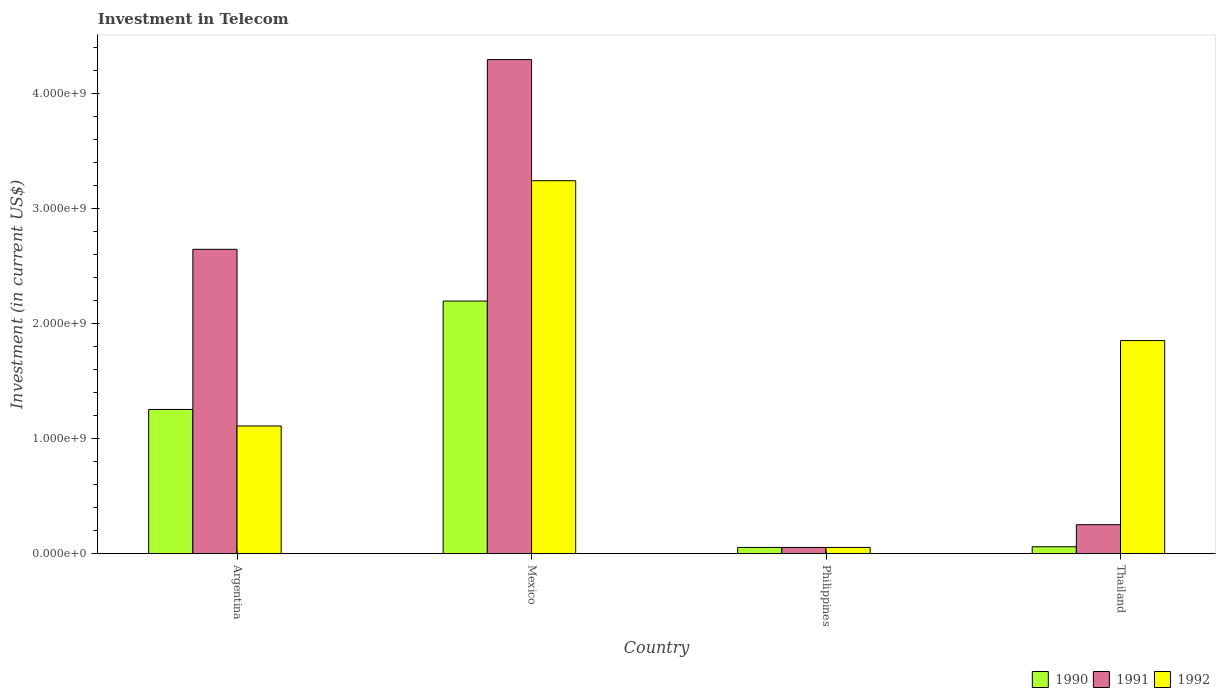How many different coloured bars are there?
Offer a very short reply. 3. How many groups of bars are there?
Give a very brief answer. 4. Are the number of bars per tick equal to the number of legend labels?
Your answer should be very brief. Yes. Are the number of bars on each tick of the X-axis equal?
Give a very brief answer. Yes. How many bars are there on the 1st tick from the left?
Your response must be concise. 3. What is the label of the 4th group of bars from the left?
Your answer should be very brief. Thailand. What is the amount invested in telecom in 1992 in Philippines?
Ensure brevity in your answer.  5.42e+07. Across all countries, what is the maximum amount invested in telecom in 1990?
Give a very brief answer. 2.20e+09. Across all countries, what is the minimum amount invested in telecom in 1990?
Your answer should be very brief. 5.42e+07. What is the total amount invested in telecom in 1992 in the graph?
Your answer should be very brief. 6.26e+09. What is the difference between the amount invested in telecom in 1990 in Argentina and that in Thailand?
Provide a succinct answer. 1.19e+09. What is the difference between the amount invested in telecom in 1990 in Thailand and the amount invested in telecom in 1991 in Mexico?
Offer a terse response. -4.24e+09. What is the average amount invested in telecom in 1992 per country?
Your response must be concise. 1.57e+09. What is the difference between the amount invested in telecom of/in 1990 and amount invested in telecom of/in 1991 in Mexico?
Give a very brief answer. -2.10e+09. What is the ratio of the amount invested in telecom in 1992 in Argentina to that in Mexico?
Provide a short and direct response. 0.34. What is the difference between the highest and the second highest amount invested in telecom in 1992?
Your response must be concise. 1.39e+09. What is the difference between the highest and the lowest amount invested in telecom in 1990?
Offer a terse response. 2.14e+09. Is the sum of the amount invested in telecom in 1990 in Argentina and Mexico greater than the maximum amount invested in telecom in 1991 across all countries?
Keep it short and to the point. No. What does the 1st bar from the right in Thailand represents?
Your answer should be very brief. 1992. Is it the case that in every country, the sum of the amount invested in telecom in 1992 and amount invested in telecom in 1991 is greater than the amount invested in telecom in 1990?
Keep it short and to the point. Yes. How many bars are there?
Ensure brevity in your answer.  12. Are all the bars in the graph horizontal?
Keep it short and to the point. No. How many countries are there in the graph?
Keep it short and to the point. 4. What is the difference between two consecutive major ticks on the Y-axis?
Your answer should be very brief. 1.00e+09. Where does the legend appear in the graph?
Offer a very short reply. Bottom right. How are the legend labels stacked?
Your answer should be compact. Horizontal. What is the title of the graph?
Ensure brevity in your answer.  Investment in Telecom. Does "1985" appear as one of the legend labels in the graph?
Ensure brevity in your answer.  No. What is the label or title of the Y-axis?
Your answer should be compact. Investment (in current US$). What is the Investment (in current US$) of 1990 in Argentina?
Your response must be concise. 1.25e+09. What is the Investment (in current US$) of 1991 in Argentina?
Your answer should be very brief. 2.65e+09. What is the Investment (in current US$) of 1992 in Argentina?
Ensure brevity in your answer.  1.11e+09. What is the Investment (in current US$) of 1990 in Mexico?
Make the answer very short. 2.20e+09. What is the Investment (in current US$) in 1991 in Mexico?
Provide a succinct answer. 4.30e+09. What is the Investment (in current US$) in 1992 in Mexico?
Ensure brevity in your answer.  3.24e+09. What is the Investment (in current US$) of 1990 in Philippines?
Ensure brevity in your answer.  5.42e+07. What is the Investment (in current US$) in 1991 in Philippines?
Ensure brevity in your answer.  5.42e+07. What is the Investment (in current US$) in 1992 in Philippines?
Give a very brief answer. 5.42e+07. What is the Investment (in current US$) in 1990 in Thailand?
Provide a succinct answer. 6.00e+07. What is the Investment (in current US$) in 1991 in Thailand?
Offer a very short reply. 2.52e+08. What is the Investment (in current US$) of 1992 in Thailand?
Provide a short and direct response. 1.85e+09. Across all countries, what is the maximum Investment (in current US$) in 1990?
Your answer should be compact. 2.20e+09. Across all countries, what is the maximum Investment (in current US$) of 1991?
Keep it short and to the point. 4.30e+09. Across all countries, what is the maximum Investment (in current US$) in 1992?
Keep it short and to the point. 3.24e+09. Across all countries, what is the minimum Investment (in current US$) of 1990?
Provide a short and direct response. 5.42e+07. Across all countries, what is the minimum Investment (in current US$) in 1991?
Provide a succinct answer. 5.42e+07. Across all countries, what is the minimum Investment (in current US$) in 1992?
Give a very brief answer. 5.42e+07. What is the total Investment (in current US$) of 1990 in the graph?
Offer a very short reply. 3.57e+09. What is the total Investment (in current US$) of 1991 in the graph?
Your answer should be very brief. 7.25e+09. What is the total Investment (in current US$) of 1992 in the graph?
Your response must be concise. 6.26e+09. What is the difference between the Investment (in current US$) of 1990 in Argentina and that in Mexico?
Provide a succinct answer. -9.43e+08. What is the difference between the Investment (in current US$) of 1991 in Argentina and that in Mexico?
Provide a succinct answer. -1.65e+09. What is the difference between the Investment (in current US$) in 1992 in Argentina and that in Mexico?
Provide a short and direct response. -2.13e+09. What is the difference between the Investment (in current US$) in 1990 in Argentina and that in Philippines?
Your answer should be very brief. 1.20e+09. What is the difference between the Investment (in current US$) of 1991 in Argentina and that in Philippines?
Your response must be concise. 2.59e+09. What is the difference between the Investment (in current US$) in 1992 in Argentina and that in Philippines?
Make the answer very short. 1.06e+09. What is the difference between the Investment (in current US$) in 1990 in Argentina and that in Thailand?
Your response must be concise. 1.19e+09. What is the difference between the Investment (in current US$) of 1991 in Argentina and that in Thailand?
Give a very brief answer. 2.40e+09. What is the difference between the Investment (in current US$) in 1992 in Argentina and that in Thailand?
Provide a succinct answer. -7.43e+08. What is the difference between the Investment (in current US$) in 1990 in Mexico and that in Philippines?
Your answer should be very brief. 2.14e+09. What is the difference between the Investment (in current US$) of 1991 in Mexico and that in Philippines?
Offer a very short reply. 4.24e+09. What is the difference between the Investment (in current US$) in 1992 in Mexico and that in Philippines?
Provide a short and direct response. 3.19e+09. What is the difference between the Investment (in current US$) of 1990 in Mexico and that in Thailand?
Offer a very short reply. 2.14e+09. What is the difference between the Investment (in current US$) in 1991 in Mexico and that in Thailand?
Your response must be concise. 4.05e+09. What is the difference between the Investment (in current US$) of 1992 in Mexico and that in Thailand?
Provide a succinct answer. 1.39e+09. What is the difference between the Investment (in current US$) in 1990 in Philippines and that in Thailand?
Provide a short and direct response. -5.80e+06. What is the difference between the Investment (in current US$) of 1991 in Philippines and that in Thailand?
Give a very brief answer. -1.98e+08. What is the difference between the Investment (in current US$) of 1992 in Philippines and that in Thailand?
Offer a terse response. -1.80e+09. What is the difference between the Investment (in current US$) of 1990 in Argentina and the Investment (in current US$) of 1991 in Mexico?
Give a very brief answer. -3.04e+09. What is the difference between the Investment (in current US$) in 1990 in Argentina and the Investment (in current US$) in 1992 in Mexico?
Provide a succinct answer. -1.99e+09. What is the difference between the Investment (in current US$) in 1991 in Argentina and the Investment (in current US$) in 1992 in Mexico?
Make the answer very short. -5.97e+08. What is the difference between the Investment (in current US$) in 1990 in Argentina and the Investment (in current US$) in 1991 in Philippines?
Ensure brevity in your answer.  1.20e+09. What is the difference between the Investment (in current US$) of 1990 in Argentina and the Investment (in current US$) of 1992 in Philippines?
Offer a terse response. 1.20e+09. What is the difference between the Investment (in current US$) in 1991 in Argentina and the Investment (in current US$) in 1992 in Philippines?
Provide a succinct answer. 2.59e+09. What is the difference between the Investment (in current US$) in 1990 in Argentina and the Investment (in current US$) in 1991 in Thailand?
Give a very brief answer. 1.00e+09. What is the difference between the Investment (in current US$) in 1990 in Argentina and the Investment (in current US$) in 1992 in Thailand?
Provide a short and direct response. -5.99e+08. What is the difference between the Investment (in current US$) in 1991 in Argentina and the Investment (in current US$) in 1992 in Thailand?
Keep it short and to the point. 7.94e+08. What is the difference between the Investment (in current US$) of 1990 in Mexico and the Investment (in current US$) of 1991 in Philippines?
Provide a succinct answer. 2.14e+09. What is the difference between the Investment (in current US$) of 1990 in Mexico and the Investment (in current US$) of 1992 in Philippines?
Your response must be concise. 2.14e+09. What is the difference between the Investment (in current US$) in 1991 in Mexico and the Investment (in current US$) in 1992 in Philippines?
Your response must be concise. 4.24e+09. What is the difference between the Investment (in current US$) in 1990 in Mexico and the Investment (in current US$) in 1991 in Thailand?
Offer a very short reply. 1.95e+09. What is the difference between the Investment (in current US$) in 1990 in Mexico and the Investment (in current US$) in 1992 in Thailand?
Your response must be concise. 3.44e+08. What is the difference between the Investment (in current US$) of 1991 in Mexico and the Investment (in current US$) of 1992 in Thailand?
Give a very brief answer. 2.44e+09. What is the difference between the Investment (in current US$) of 1990 in Philippines and the Investment (in current US$) of 1991 in Thailand?
Ensure brevity in your answer.  -1.98e+08. What is the difference between the Investment (in current US$) of 1990 in Philippines and the Investment (in current US$) of 1992 in Thailand?
Your answer should be compact. -1.80e+09. What is the difference between the Investment (in current US$) of 1991 in Philippines and the Investment (in current US$) of 1992 in Thailand?
Give a very brief answer. -1.80e+09. What is the average Investment (in current US$) in 1990 per country?
Offer a terse response. 8.92e+08. What is the average Investment (in current US$) of 1991 per country?
Make the answer very short. 1.81e+09. What is the average Investment (in current US$) of 1992 per country?
Provide a succinct answer. 1.57e+09. What is the difference between the Investment (in current US$) of 1990 and Investment (in current US$) of 1991 in Argentina?
Give a very brief answer. -1.39e+09. What is the difference between the Investment (in current US$) of 1990 and Investment (in current US$) of 1992 in Argentina?
Ensure brevity in your answer.  1.44e+08. What is the difference between the Investment (in current US$) of 1991 and Investment (in current US$) of 1992 in Argentina?
Ensure brevity in your answer.  1.54e+09. What is the difference between the Investment (in current US$) in 1990 and Investment (in current US$) in 1991 in Mexico?
Offer a very short reply. -2.10e+09. What is the difference between the Investment (in current US$) of 1990 and Investment (in current US$) of 1992 in Mexico?
Ensure brevity in your answer.  -1.05e+09. What is the difference between the Investment (in current US$) of 1991 and Investment (in current US$) of 1992 in Mexico?
Your answer should be compact. 1.05e+09. What is the difference between the Investment (in current US$) in 1990 and Investment (in current US$) in 1991 in Philippines?
Make the answer very short. 0. What is the difference between the Investment (in current US$) of 1990 and Investment (in current US$) of 1992 in Philippines?
Your answer should be very brief. 0. What is the difference between the Investment (in current US$) of 1991 and Investment (in current US$) of 1992 in Philippines?
Offer a very short reply. 0. What is the difference between the Investment (in current US$) of 1990 and Investment (in current US$) of 1991 in Thailand?
Provide a succinct answer. -1.92e+08. What is the difference between the Investment (in current US$) in 1990 and Investment (in current US$) in 1992 in Thailand?
Offer a very short reply. -1.79e+09. What is the difference between the Investment (in current US$) of 1991 and Investment (in current US$) of 1992 in Thailand?
Offer a terse response. -1.60e+09. What is the ratio of the Investment (in current US$) of 1990 in Argentina to that in Mexico?
Your response must be concise. 0.57. What is the ratio of the Investment (in current US$) of 1991 in Argentina to that in Mexico?
Keep it short and to the point. 0.62. What is the ratio of the Investment (in current US$) in 1992 in Argentina to that in Mexico?
Keep it short and to the point. 0.34. What is the ratio of the Investment (in current US$) in 1990 in Argentina to that in Philippines?
Provide a succinct answer. 23.15. What is the ratio of the Investment (in current US$) of 1991 in Argentina to that in Philippines?
Provide a succinct answer. 48.86. What is the ratio of the Investment (in current US$) in 1992 in Argentina to that in Philippines?
Offer a very short reply. 20.5. What is the ratio of the Investment (in current US$) in 1990 in Argentina to that in Thailand?
Offer a terse response. 20.91. What is the ratio of the Investment (in current US$) in 1991 in Argentina to that in Thailand?
Your answer should be very brief. 10.51. What is the ratio of the Investment (in current US$) of 1992 in Argentina to that in Thailand?
Your answer should be compact. 0.6. What is the ratio of the Investment (in current US$) in 1990 in Mexico to that in Philippines?
Offer a terse response. 40.55. What is the ratio of the Investment (in current US$) of 1991 in Mexico to that in Philippines?
Provide a short and direct response. 79.32. What is the ratio of the Investment (in current US$) of 1992 in Mexico to that in Philippines?
Provide a succinct answer. 59.87. What is the ratio of the Investment (in current US$) of 1990 in Mexico to that in Thailand?
Your answer should be very brief. 36.63. What is the ratio of the Investment (in current US$) of 1991 in Mexico to that in Thailand?
Your answer should be compact. 17.06. What is the ratio of the Investment (in current US$) in 1992 in Mexico to that in Thailand?
Ensure brevity in your answer.  1.75. What is the ratio of the Investment (in current US$) in 1990 in Philippines to that in Thailand?
Your answer should be compact. 0.9. What is the ratio of the Investment (in current US$) of 1991 in Philippines to that in Thailand?
Offer a terse response. 0.22. What is the ratio of the Investment (in current US$) in 1992 in Philippines to that in Thailand?
Your answer should be very brief. 0.03. What is the difference between the highest and the second highest Investment (in current US$) of 1990?
Keep it short and to the point. 9.43e+08. What is the difference between the highest and the second highest Investment (in current US$) of 1991?
Give a very brief answer. 1.65e+09. What is the difference between the highest and the second highest Investment (in current US$) of 1992?
Your answer should be compact. 1.39e+09. What is the difference between the highest and the lowest Investment (in current US$) in 1990?
Your answer should be compact. 2.14e+09. What is the difference between the highest and the lowest Investment (in current US$) in 1991?
Keep it short and to the point. 4.24e+09. What is the difference between the highest and the lowest Investment (in current US$) of 1992?
Offer a terse response. 3.19e+09. 